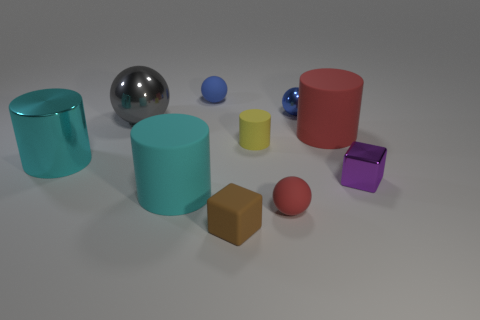Are there any other things that have the same color as the tiny matte cube?
Your response must be concise. No. What number of rubber objects are tiny blue objects or small cylinders?
Your response must be concise. 2. Are the big cylinder right of the cyan rubber object and the cube in front of the tiny purple cube made of the same material?
Keep it short and to the point. Yes. Are there any small red matte blocks?
Keep it short and to the point. No. There is a red rubber object in front of the cyan matte cylinder; is its shape the same as the big red object behind the small brown rubber block?
Your answer should be very brief. No. Are there any big purple balls that have the same material as the brown thing?
Your answer should be compact. No. Are the tiny sphere to the left of the matte cube and the big gray object made of the same material?
Offer a very short reply. No. Is the number of tiny rubber balls that are right of the big gray sphere greater than the number of cubes to the left of the yellow rubber cylinder?
Give a very brief answer. Yes. The shiny block that is the same size as the brown thing is what color?
Ensure brevity in your answer.  Purple. Is there a large matte cylinder that has the same color as the large metallic cylinder?
Provide a short and direct response. Yes. 